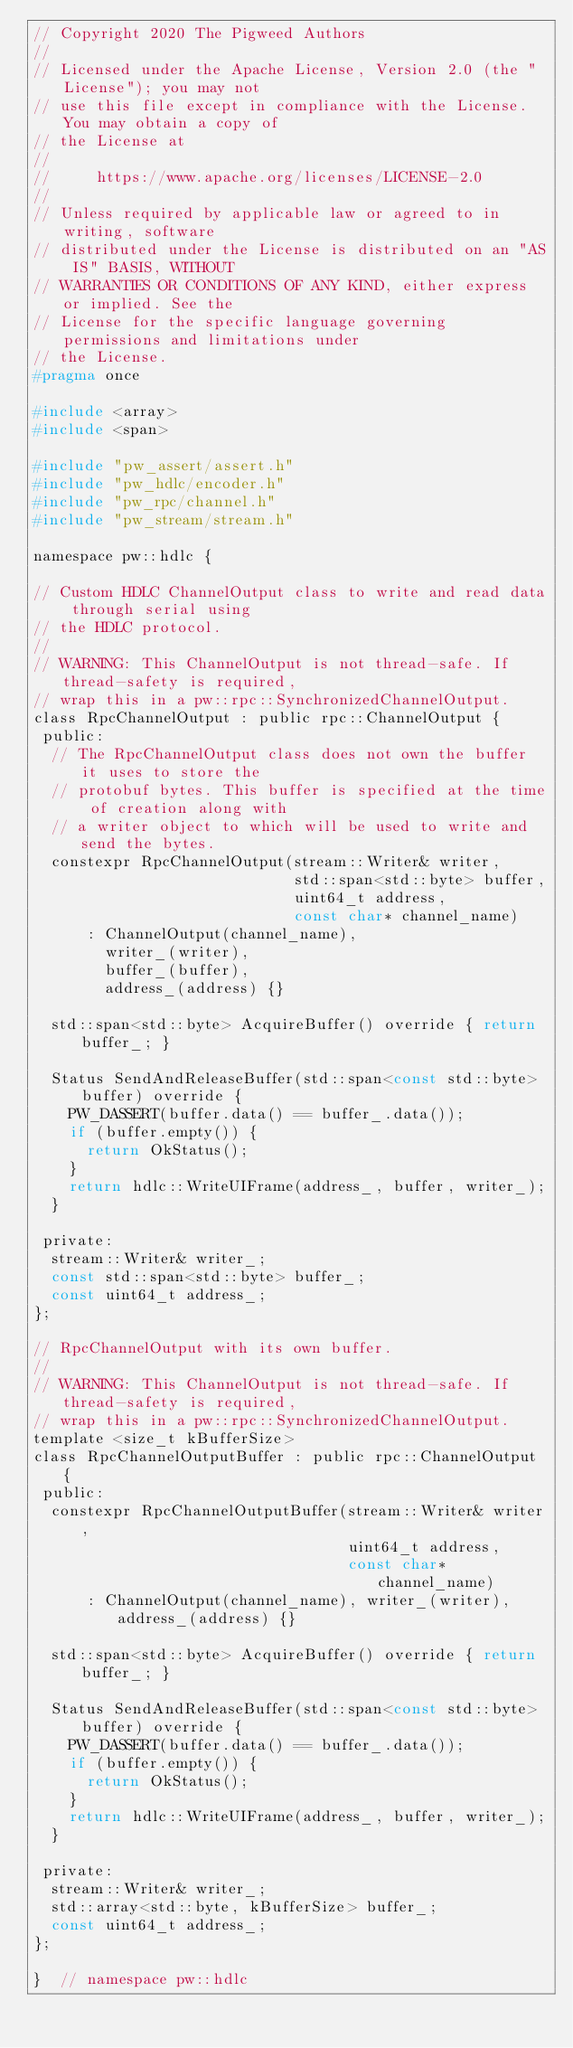Convert code to text. <code><loc_0><loc_0><loc_500><loc_500><_C_>// Copyright 2020 The Pigweed Authors
//
// Licensed under the Apache License, Version 2.0 (the "License"); you may not
// use this file except in compliance with the License. You may obtain a copy of
// the License at
//
//     https://www.apache.org/licenses/LICENSE-2.0
//
// Unless required by applicable law or agreed to in writing, software
// distributed under the License is distributed on an "AS IS" BASIS, WITHOUT
// WARRANTIES OR CONDITIONS OF ANY KIND, either express or implied. See the
// License for the specific language governing permissions and limitations under
// the License.
#pragma once

#include <array>
#include <span>

#include "pw_assert/assert.h"
#include "pw_hdlc/encoder.h"
#include "pw_rpc/channel.h"
#include "pw_stream/stream.h"

namespace pw::hdlc {

// Custom HDLC ChannelOutput class to write and read data through serial using
// the HDLC protocol.
//
// WARNING: This ChannelOutput is not thread-safe. If thread-safety is required,
// wrap this in a pw::rpc::SynchronizedChannelOutput.
class RpcChannelOutput : public rpc::ChannelOutput {
 public:
  // The RpcChannelOutput class does not own the buffer it uses to store the
  // protobuf bytes. This buffer is specified at the time of creation along with
  // a writer object to which will be used to write and send the bytes.
  constexpr RpcChannelOutput(stream::Writer& writer,
                             std::span<std::byte> buffer,
                             uint64_t address,
                             const char* channel_name)
      : ChannelOutput(channel_name),
        writer_(writer),
        buffer_(buffer),
        address_(address) {}

  std::span<std::byte> AcquireBuffer() override { return buffer_; }

  Status SendAndReleaseBuffer(std::span<const std::byte> buffer) override {
    PW_DASSERT(buffer.data() == buffer_.data());
    if (buffer.empty()) {
      return OkStatus();
    }
    return hdlc::WriteUIFrame(address_, buffer, writer_);
  }

 private:
  stream::Writer& writer_;
  const std::span<std::byte> buffer_;
  const uint64_t address_;
};

// RpcChannelOutput with its own buffer.
//
// WARNING: This ChannelOutput is not thread-safe. If thread-safety is required,
// wrap this in a pw::rpc::SynchronizedChannelOutput.
template <size_t kBufferSize>
class RpcChannelOutputBuffer : public rpc::ChannelOutput {
 public:
  constexpr RpcChannelOutputBuffer(stream::Writer& writer,
                                   uint64_t address,
                                   const char* channel_name)
      : ChannelOutput(channel_name), writer_(writer), address_(address) {}

  std::span<std::byte> AcquireBuffer() override { return buffer_; }

  Status SendAndReleaseBuffer(std::span<const std::byte> buffer) override {
    PW_DASSERT(buffer.data() == buffer_.data());
    if (buffer.empty()) {
      return OkStatus();
    }
    return hdlc::WriteUIFrame(address_, buffer, writer_);
  }

 private:
  stream::Writer& writer_;
  std::array<std::byte, kBufferSize> buffer_;
  const uint64_t address_;
};

}  // namespace pw::hdlc
</code> 